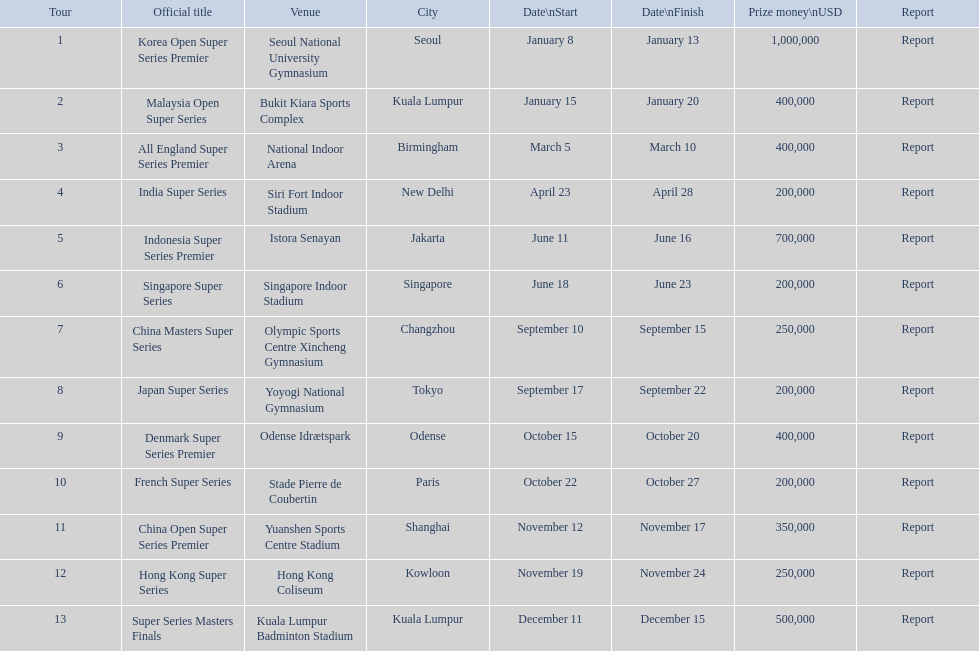What are the complete list of titles? Korea Open Super Series Premier, Malaysia Open Super Series, All England Super Series Premier, India Super Series, Indonesia Super Series Premier, Singapore Super Series, China Masters Super Series, Japan Super Series, Denmark Super Series Premier, French Super Series, China Open Super Series Premier, Hong Kong Super Series, Super Series Masters Finals. When did each event occur? January 8, January 15, March 5, April 23, June 11, June 18, September 10, September 17, October 15, October 22, November 12, November 19, December 11. Which one happened in december? Super Series Masters Finals. 